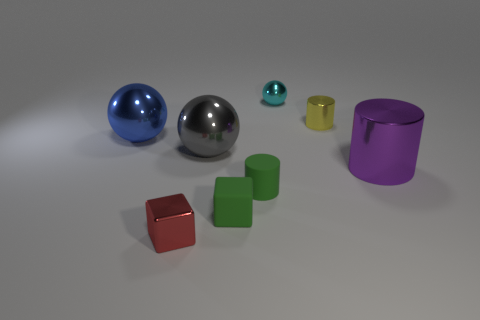Add 1 gray rubber spheres. How many objects exist? 9 Subtract all blocks. How many objects are left? 6 Subtract 1 gray balls. How many objects are left? 7 Subtract all tiny cyan spheres. Subtract all small green cylinders. How many objects are left? 6 Add 1 tiny red metallic cubes. How many tiny red metallic cubes are left? 2 Add 6 red shiny cubes. How many red shiny cubes exist? 7 